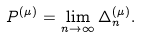Convert formula to latex. <formula><loc_0><loc_0><loc_500><loc_500>P ^ { ( \mu ) } = \lim _ { n \rightarrow \infty } \Delta ^ { ( \mu ) } _ { n } .</formula> 